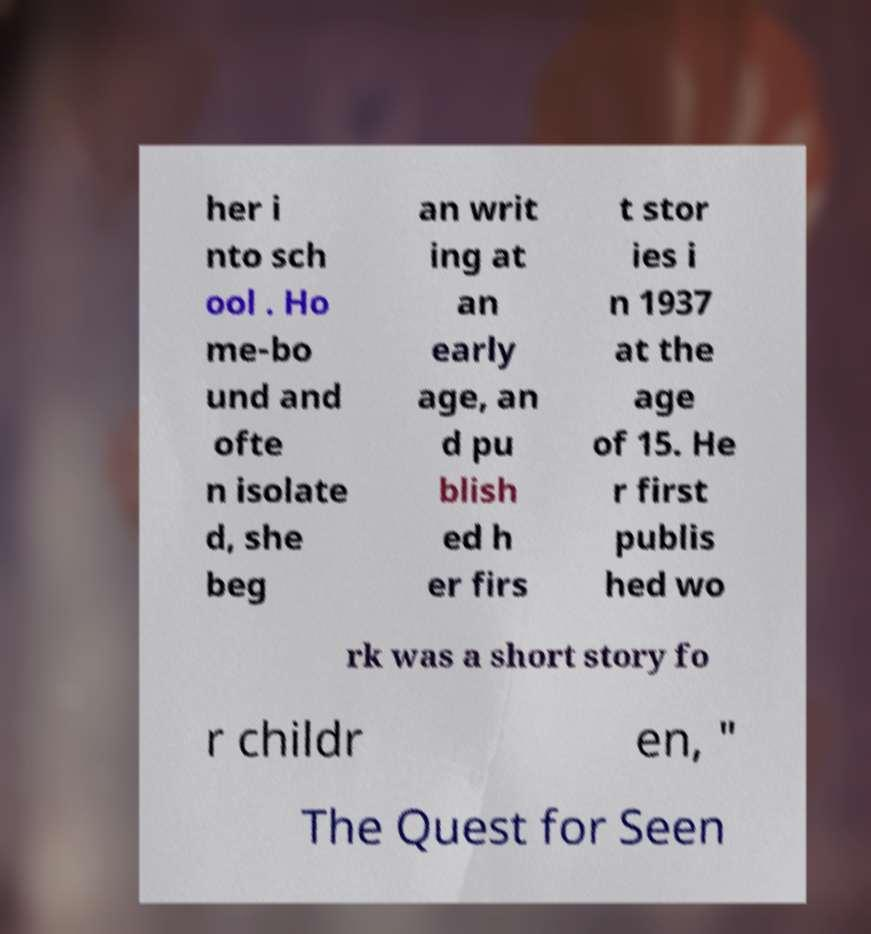Please read and relay the text visible in this image. What does it say? her i nto sch ool . Ho me-bo und and ofte n isolate d, she beg an writ ing at an early age, an d pu blish ed h er firs t stor ies i n 1937 at the age of 15. He r first publis hed wo rk was a short story fo r childr en, " The Quest for Seen 